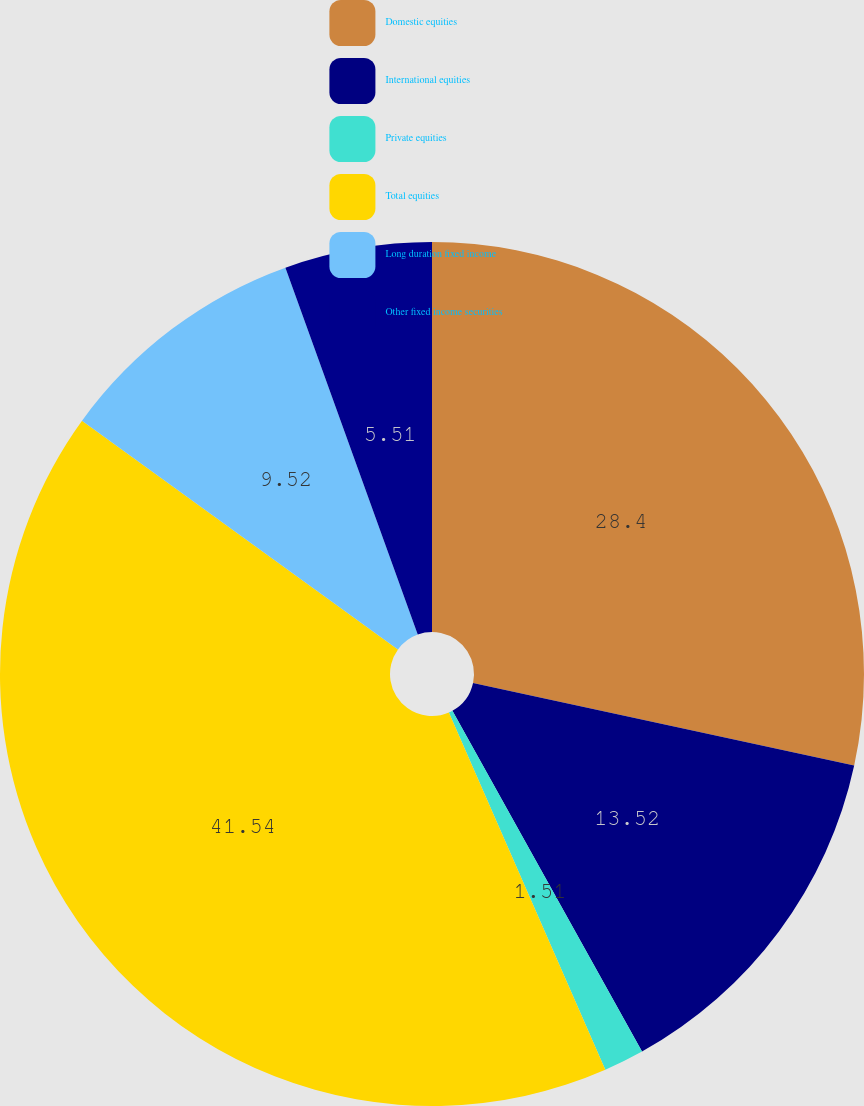Convert chart to OTSL. <chart><loc_0><loc_0><loc_500><loc_500><pie_chart><fcel>Domestic equities<fcel>International equities<fcel>Private equities<fcel>Total equities<fcel>Long duration fixed income<fcel>Other fixed income securities<nl><fcel>28.4%<fcel>13.52%<fcel>1.51%<fcel>41.54%<fcel>9.52%<fcel>5.51%<nl></chart> 